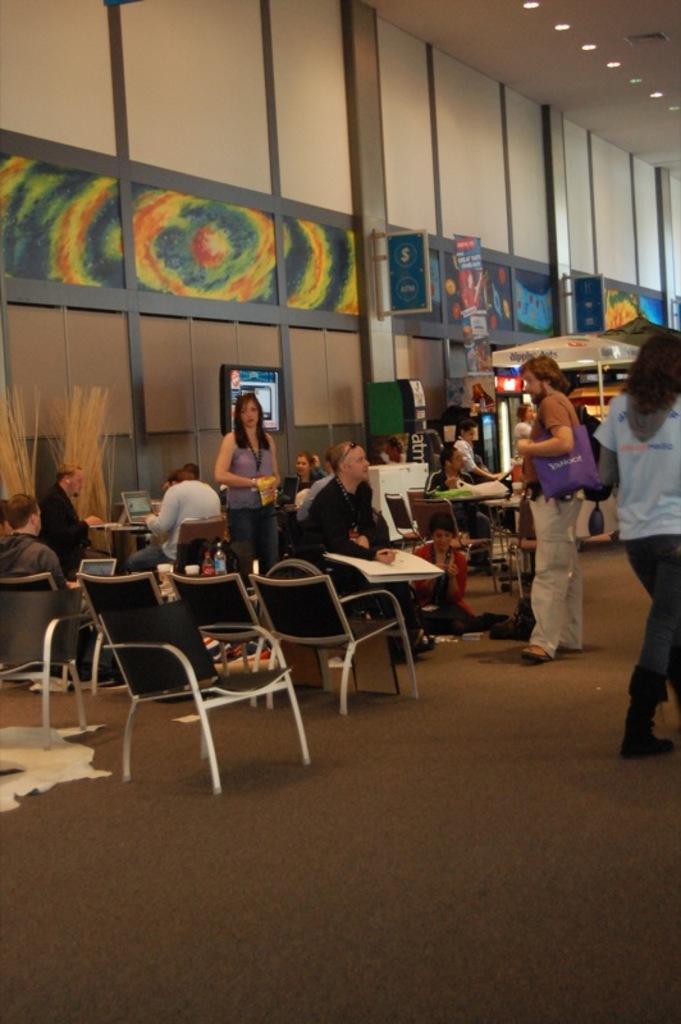In one or two sentences, can you explain what this image depicts? In this image I can see few people some are sitting on the chairs and some are standing. The person in front wearing brown shirt, cream pant and purple color bag. Background I can see a board which is in blue color attached to the wall. 